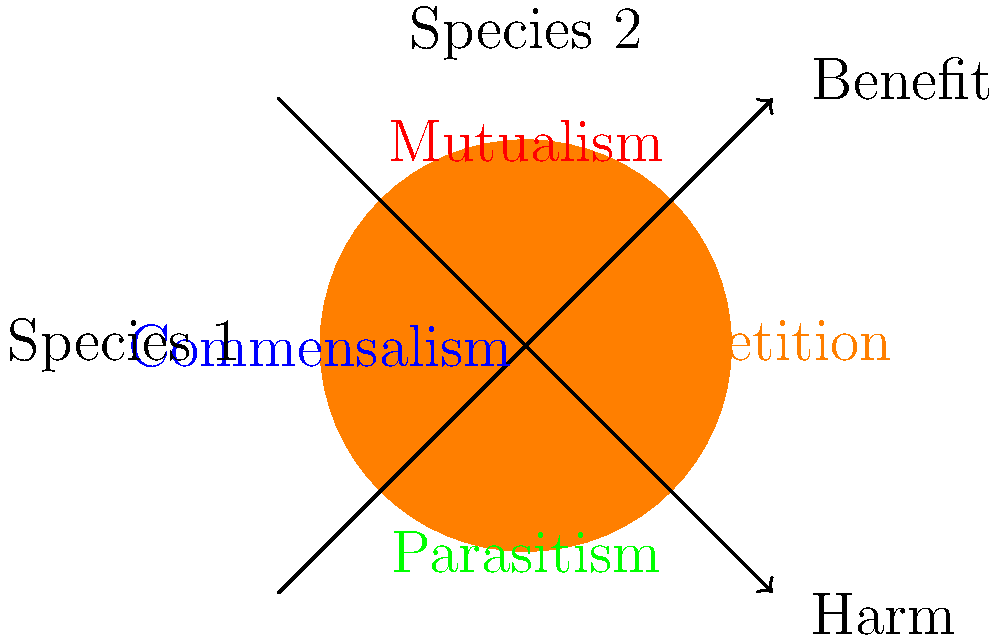Analyze the diagram illustrating different types of symbiotic relationships. Which quadrant represents a relationship where one species benefits while the other is neither harmed nor helped? Explain how this relationship differs from the others shown and provide an example from nature. To answer this question, let's analyze each quadrant of the diagram:

1. Top-right (blue): Mutualism - Both species benefit from the relationship.
2. Top-left (red): Commensalism - One species benefits while the other is unaffected.
3. Bottom-left (green): Parasitism - One species benefits while the other is harmed.
4. Bottom-right (orange): Competition - Both species are harmed by the relationship.

The relationship where one species benefits while the other is neither harmed nor helped is represented in the top-left quadrant, labeled as "Commensalism."

Commensalism differs from the other relationships in the following ways:
- Unlike mutualism, only one species benefits.
- Unlike parasitism, the non-benefiting species is not harmed.
- Unlike competition, there is no negative impact on either species.

An example of commensalism in nature is the relationship between remora fish and sharks. Remora fish attach themselves to sharks and feed on the shark's leftover food particles. The remora benefits from this relationship by obtaining food and transportation, while the shark is generally unaffected.

This type of relationship is particularly interesting from a biological perspective as it demonstrates how species can coexist and even benefit from one another without causing harm, which is relevant to understanding ecosystem dynamics and species interactions.
Answer: Commensalism (top-left quadrant) 